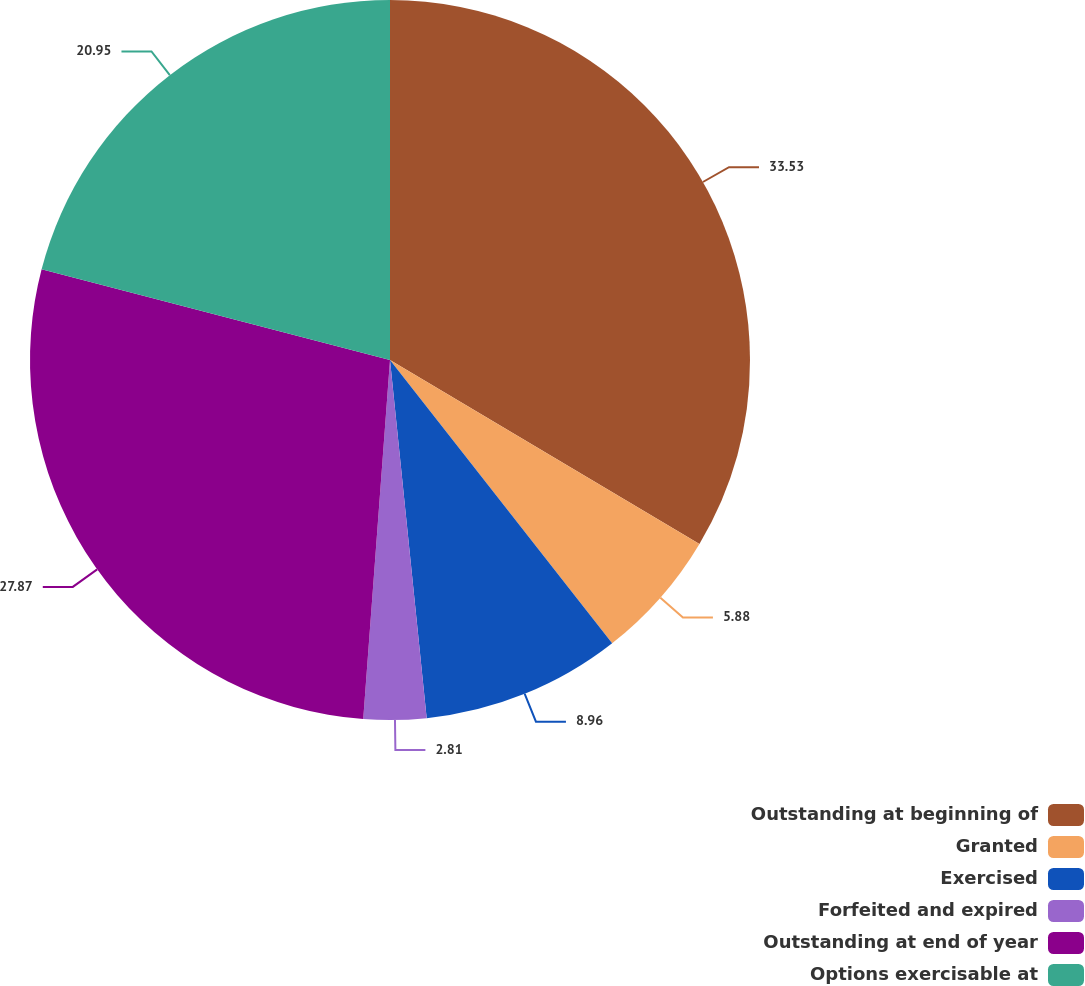Convert chart. <chart><loc_0><loc_0><loc_500><loc_500><pie_chart><fcel>Outstanding at beginning of<fcel>Granted<fcel>Exercised<fcel>Forfeited and expired<fcel>Outstanding at end of year<fcel>Options exercisable at<nl><fcel>33.54%<fcel>5.88%<fcel>8.96%<fcel>2.81%<fcel>27.87%<fcel>20.95%<nl></chart> 